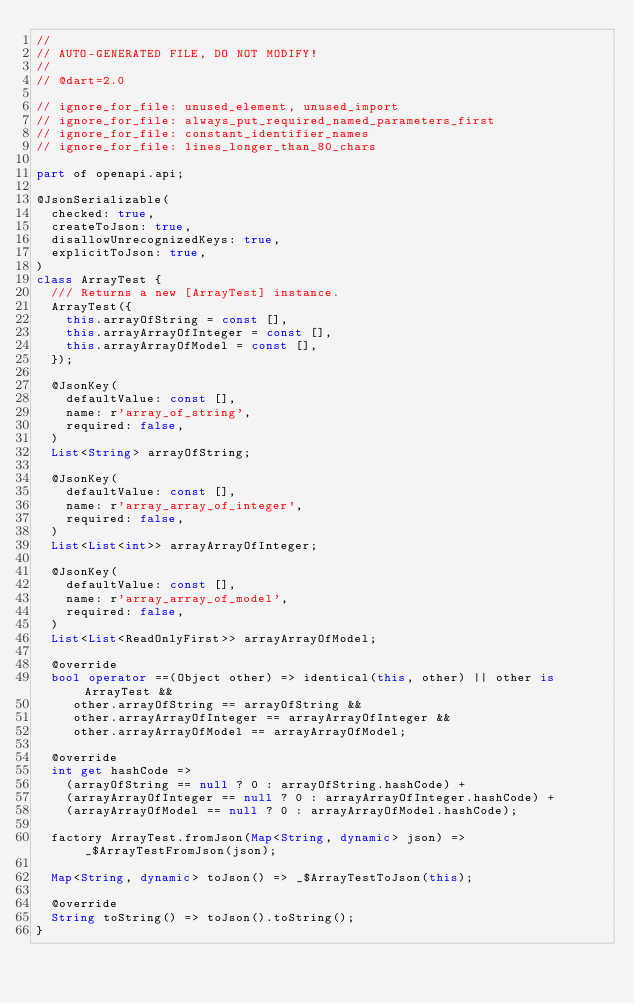<code> <loc_0><loc_0><loc_500><loc_500><_Dart_>//
// AUTO-GENERATED FILE, DO NOT MODIFY!
//
// @dart=2.0

// ignore_for_file: unused_element, unused_import
// ignore_for_file: always_put_required_named_parameters_first
// ignore_for_file: constant_identifier_names
// ignore_for_file: lines_longer_than_80_chars

part of openapi.api;

@JsonSerializable(
  checked: true,
  createToJson: true,
  disallowUnrecognizedKeys: true,
  explicitToJson: true,
)
class ArrayTest {
  /// Returns a new [ArrayTest] instance.
  ArrayTest({
    this.arrayOfString = const [],
    this.arrayArrayOfInteger = const [],
    this.arrayArrayOfModel = const [],
  });

  @JsonKey(
    defaultValue: const [],
    name: r'array_of_string',
    required: false,
  )
  List<String> arrayOfString;

  @JsonKey(
    defaultValue: const [],
    name: r'array_array_of_integer',
    required: false,
  )
  List<List<int>> arrayArrayOfInteger;

  @JsonKey(
    defaultValue: const [],
    name: r'array_array_of_model',
    required: false,
  )
  List<List<ReadOnlyFirst>> arrayArrayOfModel;

  @override
  bool operator ==(Object other) => identical(this, other) || other is ArrayTest &&
     other.arrayOfString == arrayOfString &&
     other.arrayArrayOfInteger == arrayArrayOfInteger &&
     other.arrayArrayOfModel == arrayArrayOfModel;

  @override
  int get hashCode =>
    (arrayOfString == null ? 0 : arrayOfString.hashCode) +
    (arrayArrayOfInteger == null ? 0 : arrayArrayOfInteger.hashCode) +
    (arrayArrayOfModel == null ? 0 : arrayArrayOfModel.hashCode);

  factory ArrayTest.fromJson(Map<String, dynamic> json) => _$ArrayTestFromJson(json);

  Map<String, dynamic> toJson() => _$ArrayTestToJson(this);

  @override
  String toString() => toJson().toString();
}

</code> 